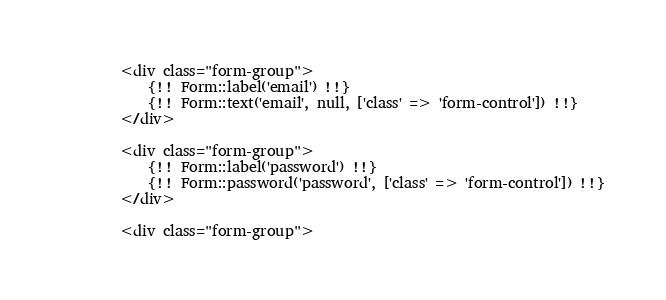<code> <loc_0><loc_0><loc_500><loc_500><_PHP_>		<div class="form-group">
			{!! Form::label('email') !!}
			{!! Form::text('email', null, ['class' => 'form-control']) !!}
		</div>

		<div class="form-group">
			{!! Form::label('password') !!}
			{!! Form::password('password', ['class' => 'form-control']) !!}
		</div>

		<div class="form-group"></code> 